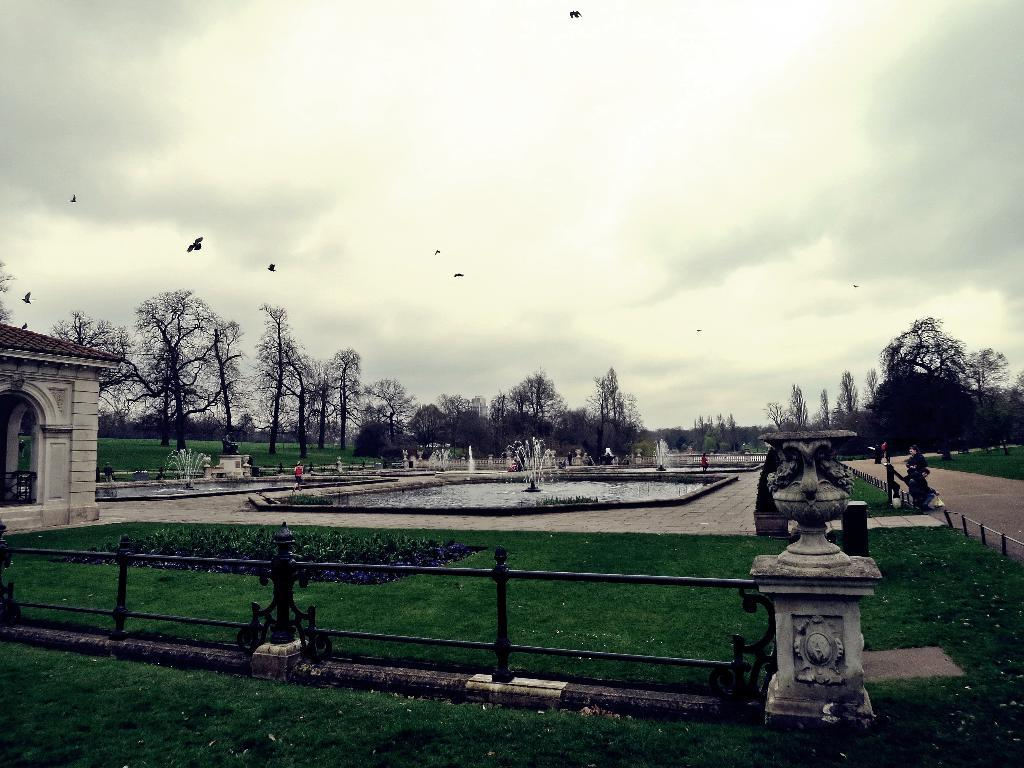What type of pathway is visible in the image? There is a walkway in the image. What type of vegetation is present in the image? Grass is present in the image. What feature is present to provide safety along the walkway? There is a railing in the image. What structures are visible along the walkway? Poles are visible in the image. What water feature can be seen in the image? There is a fountain in the image. What type of vegetation is visible in the background of the image? There are trees in the background of the image. What is the condition of the sky in the image? The sky is clear in the image. What type of reaction can be seen from the trees in the image? There are no reactions from the trees in the image, as trees do not have the ability to react. 